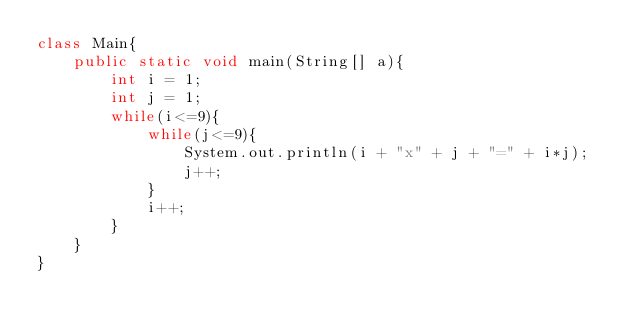<code> <loc_0><loc_0><loc_500><loc_500><_Java_>class Main{
	public static void main(String[] a){
		int i = 1;
		int j = 1;
		while(i<=9){
			while(j<=9){
				System.out.println(i + "x" + j + "=" + i*j);
				j++;
			}
			i++;
		}
	}
}</code> 